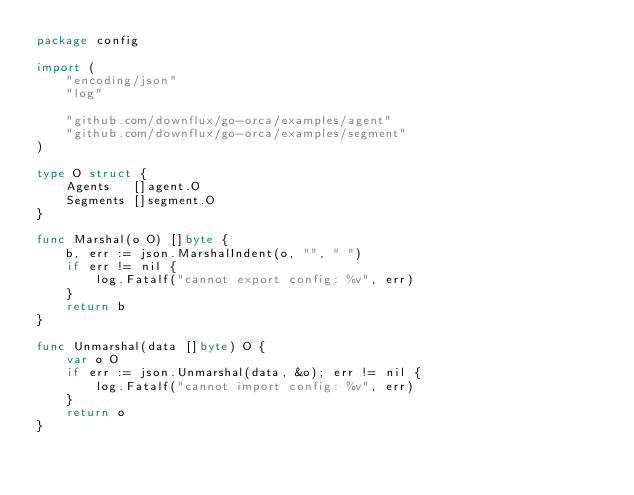Convert code to text. <code><loc_0><loc_0><loc_500><loc_500><_Go_>package config

import (
	"encoding/json"
	"log"

	"github.com/downflux/go-orca/examples/agent"
	"github.com/downflux/go-orca/examples/segment"
)

type O struct {
	Agents   []agent.O
	Segments []segment.O
}

func Marshal(o O) []byte {
	b, err := json.MarshalIndent(o, "", " ")
	if err != nil {
		log.Fatalf("cannot export config: %v", err)
	}
	return b
}

func Unmarshal(data []byte) O {
	var o O
	if err := json.Unmarshal(data, &o); err != nil {
		log.Fatalf("cannot import config: %v", err)
	}
	return o
}
</code> 